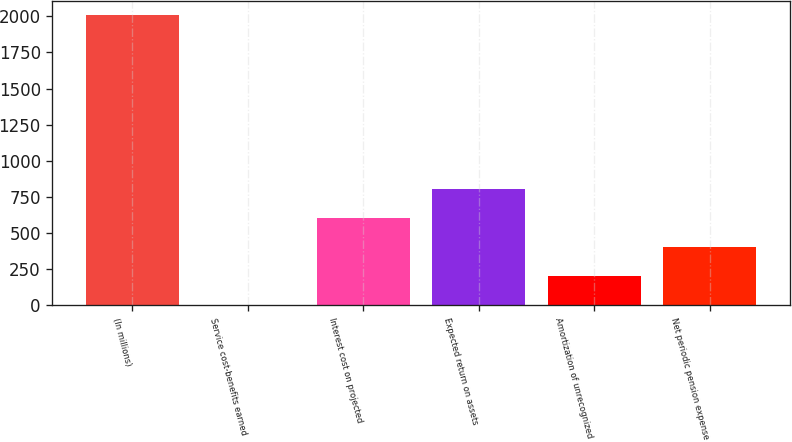Convert chart. <chart><loc_0><loc_0><loc_500><loc_500><bar_chart><fcel>(In millions)<fcel>Service cost-benefits earned<fcel>Interest cost on projected<fcel>Expected return on assets<fcel>Amortization of unrecognized<fcel>Net periodic pension expense<nl><fcel>2006<fcel>6<fcel>606<fcel>806<fcel>206<fcel>406<nl></chart> 